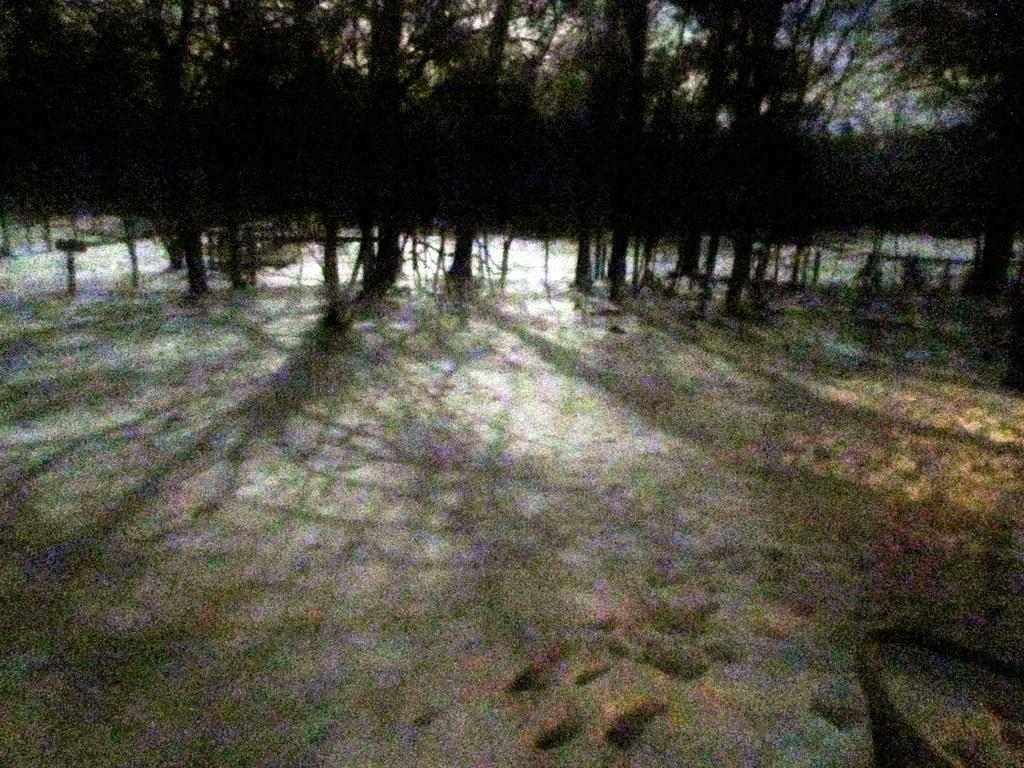What type of natural elements can be seen in the background of the image? There are trees in the background of the image. What effect do the trees have on the ground in the image? Shadows of trees are visible at the bottom of the image. How many actors are performing in the image? There are no actors present in the image; it features trees and their shadows. What type of activity are the boys engaged in within the image? There are no boys present in the image; it features trees and their shadows. 